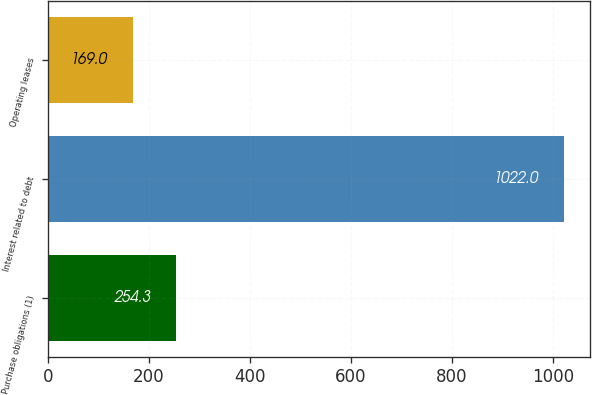Convert chart. <chart><loc_0><loc_0><loc_500><loc_500><bar_chart><fcel>Purchase obligations (1)<fcel>Interest related to debt<fcel>Operating leases<nl><fcel>254.3<fcel>1022<fcel>169<nl></chart> 